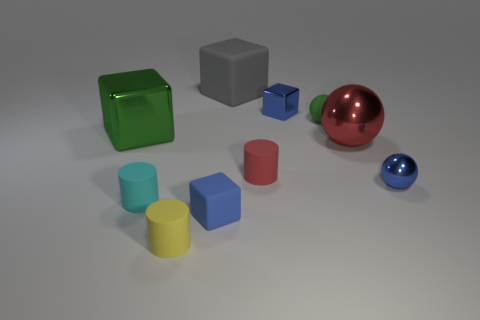Subtract all blue metallic cubes. How many cubes are left? 3 Subtract all red spheres. How many spheres are left? 2 Subtract all yellow balls. How many red cylinders are left? 1 Subtract all balls. How many objects are left? 7 Subtract all purple rubber blocks. Subtract all blue metallic things. How many objects are left? 8 Add 9 large red balls. How many large red balls are left? 10 Add 7 blue shiny objects. How many blue shiny objects exist? 9 Subtract 0 purple cylinders. How many objects are left? 10 Subtract 1 cylinders. How many cylinders are left? 2 Subtract all brown cylinders. Subtract all cyan blocks. How many cylinders are left? 3 